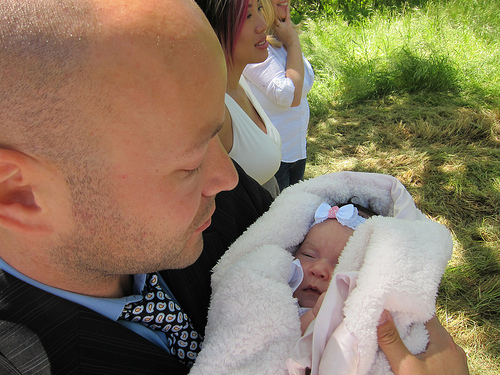<image>
Is the baby on the man? Yes. Looking at the image, I can see the baby is positioned on top of the man, with the man providing support. Is there a baby next to the blanket? No. The baby is not positioned next to the blanket. They are located in different areas of the scene. Is the man in front of the girl? Yes. The man is positioned in front of the girl, appearing closer to the camera viewpoint. 